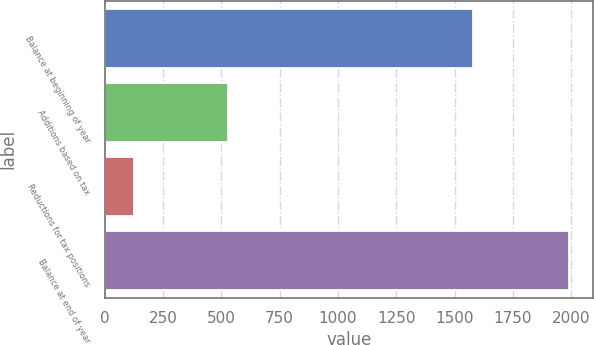<chart> <loc_0><loc_0><loc_500><loc_500><bar_chart><fcel>Balance at beginning of year<fcel>Additions based on tax<fcel>Reductions for tax positions<fcel>Balance at end of year<nl><fcel>1579<fcel>527<fcel>127<fcel>1993<nl></chart> 